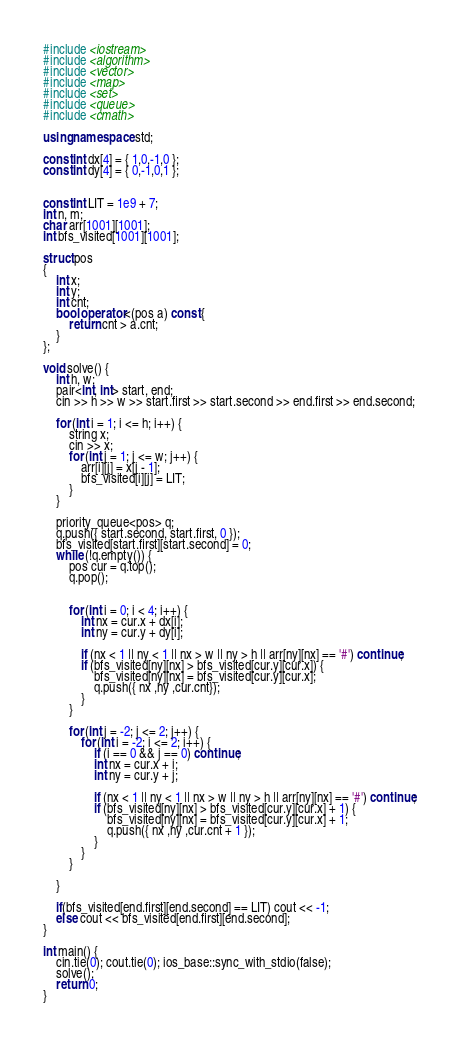<code> <loc_0><loc_0><loc_500><loc_500><_C++_>#include <iostream>
#include <algorithm>
#include <vector>
#include <map>
#include <set>
#include <queue>
#include <cmath>

using namespace std;

const int dx[4] = { 1,0,-1,0 };
const int dy[4] = { 0,-1,0,1 };


const int LIT = 1e9 + 7;
int n, m;
char arr[1001][1001];
int bfs_visited[1001][1001];

struct pos
{
    int x;
    int y;
    int cnt;
    bool operator<(pos a) const {
        return cnt > a.cnt;
    }
};

void solve() {
    int h, w;
    pair<int, int> start, end;
    cin >> h >> w >> start.first >> start.second >> end.first >> end.second;

    for (int i = 1; i <= h; i++) {
        string x;
        cin >> x;
        for (int j = 1; j <= w; j++) {
            arr[i][j] = x[j - 1];
            bfs_visited[i][j] = LIT;
        }
    }

    priority_queue<pos> q;
    q.push({ start.second, start.first, 0 });
    bfs_visited[start.first][start.second] = 0;
    while (!q.empty()) {
        pos cur = q.top();
        q.pop();


        for (int i = 0; i < 4; i++) {
            int nx = cur.x + dx[i];
            int ny = cur.y + dy[i];

            if (nx < 1 || ny < 1 || nx > w || ny > h || arr[ny][nx] == '#') continue;
            if (bfs_visited[ny][nx] > bfs_visited[cur.y][cur.x]) {
                bfs_visited[ny][nx] = bfs_visited[cur.y][cur.x];
                q.push({ nx ,ny ,cur.cnt});
            }
        }

        for (int j = -2; j <= 2; j++) {
            for (int i = -2; i <= 2; i++) {
                if (i == 0 && j == 0) continue;
                int nx = cur.x + i;
                int ny = cur.y + j;

                if (nx < 1 || ny < 1 || nx > w || ny > h || arr[ny][nx] == '#') continue;
                if (bfs_visited[ny][nx] > bfs_visited[cur.y][cur.x] + 1) {
                    bfs_visited[ny][nx] = bfs_visited[cur.y][cur.x] + 1;
                    q.push({ nx ,ny ,cur.cnt + 1 });
                }
            }
        }

    }

    if(bfs_visited[end.first][end.second] == LIT) cout << -1;
    else cout << bfs_visited[end.first][end.second];
}

int main() {
    cin.tie(0); cout.tie(0); ios_base::sync_with_stdio(false);
    solve();
    return 0;
}
</code> 